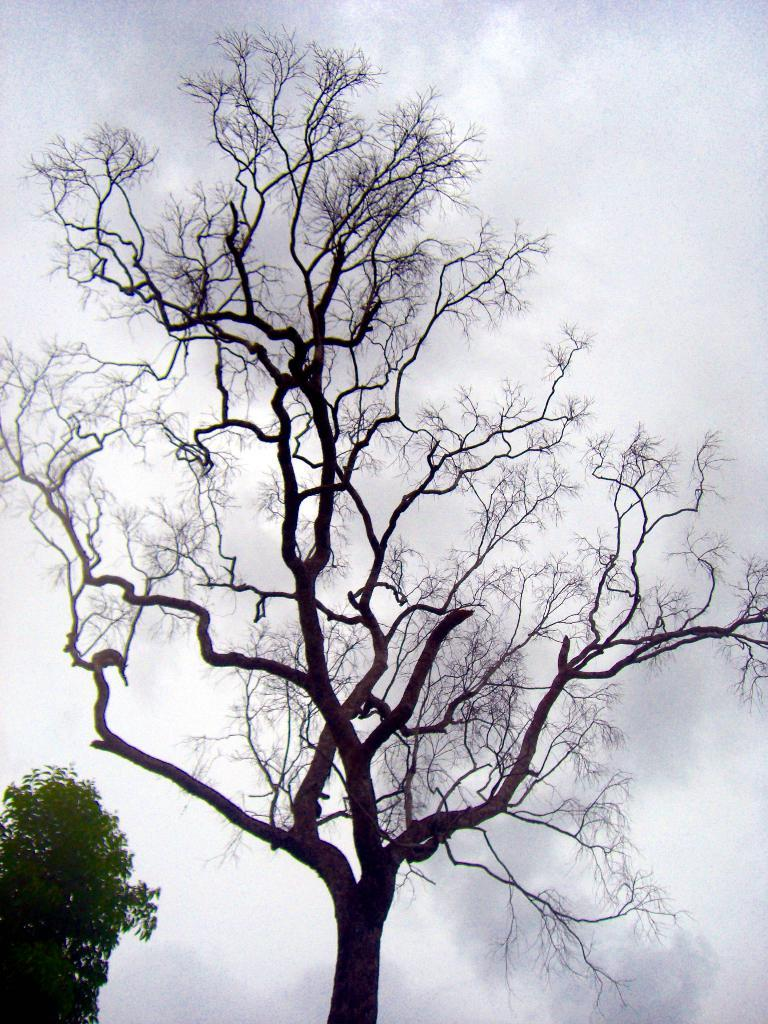What type of tree is located in the center of the image? There is a big bare tree in the image. What other type of tree can be seen in the image? There is a green tree on the left side of the image. What is visible in the background of the image? The sky is visible in the background of the image. What is the condition of the sky in the image? The sky is cloudy in the image. What type of plantation can be seen in the image? There is no plantation present in the image; it features a big bare tree and a green tree. What does the mother do in the image? There is no mother present in the image. 